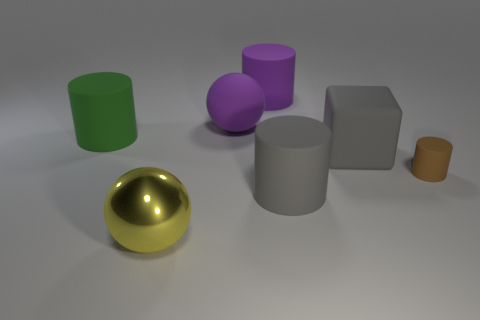There is a brown matte thing; is it the same shape as the large gray thing that is behind the gray matte cylinder?
Ensure brevity in your answer.  No. What material is the sphere right of the ball that is in front of the small brown cylinder?
Keep it short and to the point. Rubber. Are there the same number of brown cylinders on the left side of the gray matte cylinder and tiny blue blocks?
Your answer should be very brief. Yes. Is there anything else that has the same material as the gray cylinder?
Your response must be concise. Yes. There is a large rubber cylinder in front of the big green rubber object; does it have the same color as the sphere behind the small brown cylinder?
Your response must be concise. No. What number of things are both in front of the green matte thing and behind the yellow shiny sphere?
Offer a terse response. 3. Is the number of yellow balls the same as the number of large objects?
Make the answer very short. No. How many other things are the same shape as the big green rubber object?
Make the answer very short. 3. Is the number of large green matte things that are in front of the brown object greater than the number of large yellow matte blocks?
Make the answer very short. No. The large cylinder that is left of the large purple rubber sphere is what color?
Your response must be concise. Green. 